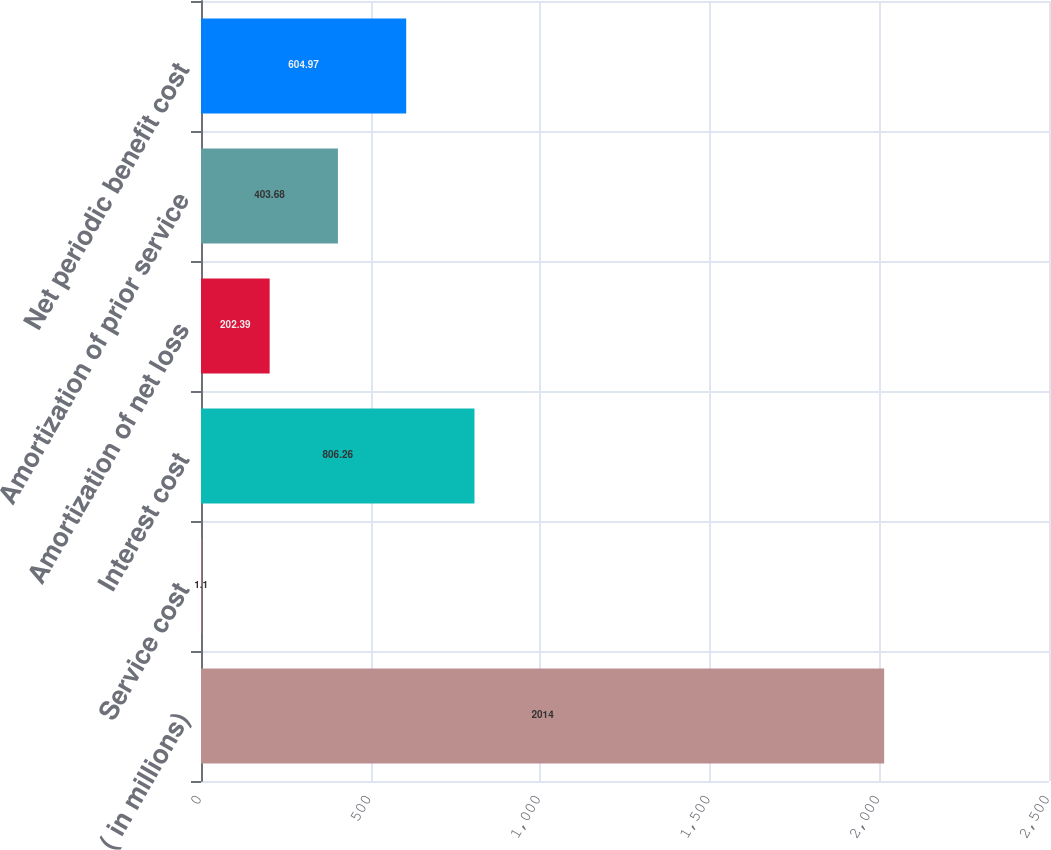Convert chart. <chart><loc_0><loc_0><loc_500><loc_500><bar_chart><fcel>( in millions)<fcel>Service cost<fcel>Interest cost<fcel>Amortization of net loss<fcel>Amortization of prior service<fcel>Net periodic benefit cost<nl><fcel>2014<fcel>1.1<fcel>806.26<fcel>202.39<fcel>403.68<fcel>604.97<nl></chart> 